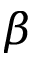Convert formula to latex. <formula><loc_0><loc_0><loc_500><loc_500>\beta</formula> 